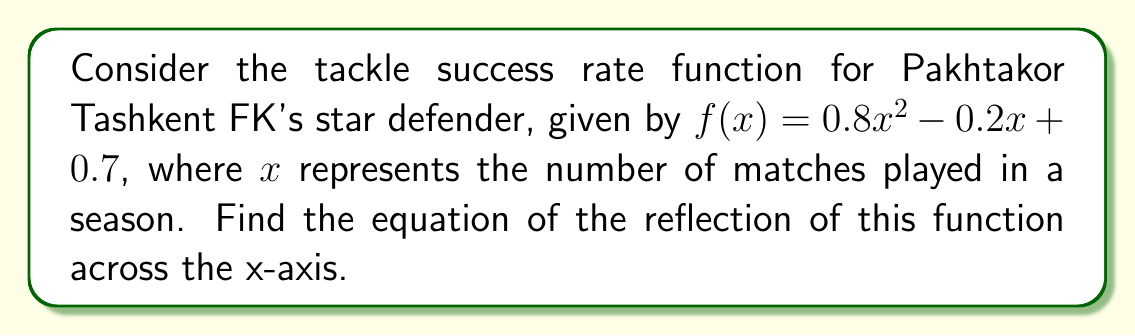What is the answer to this math problem? To reflect a function across the x-axis, we need to negate the y-values of the original function. This is equivalent to multiplying the entire function by -1. Let's follow these steps:

1) The original function is:
   $f(x) = 0.8x^2 - 0.2x + 0.7$

2) To reflect it across the x-axis, multiply the entire function by -1:
   $g(x) = -1 \cdot f(x)$

3) Distribute the negative sign:
   $g(x) = -(0.8x^2 - 0.2x + 0.7)$

4) Simplify by negating each term:
   $g(x) = -0.8x^2 + 0.2x - 0.7$

This new function $g(x)$ represents the reflection of the original tackle success rate function across the x-axis.
Answer: $g(x) = -0.8x^2 + 0.2x - 0.7$ 